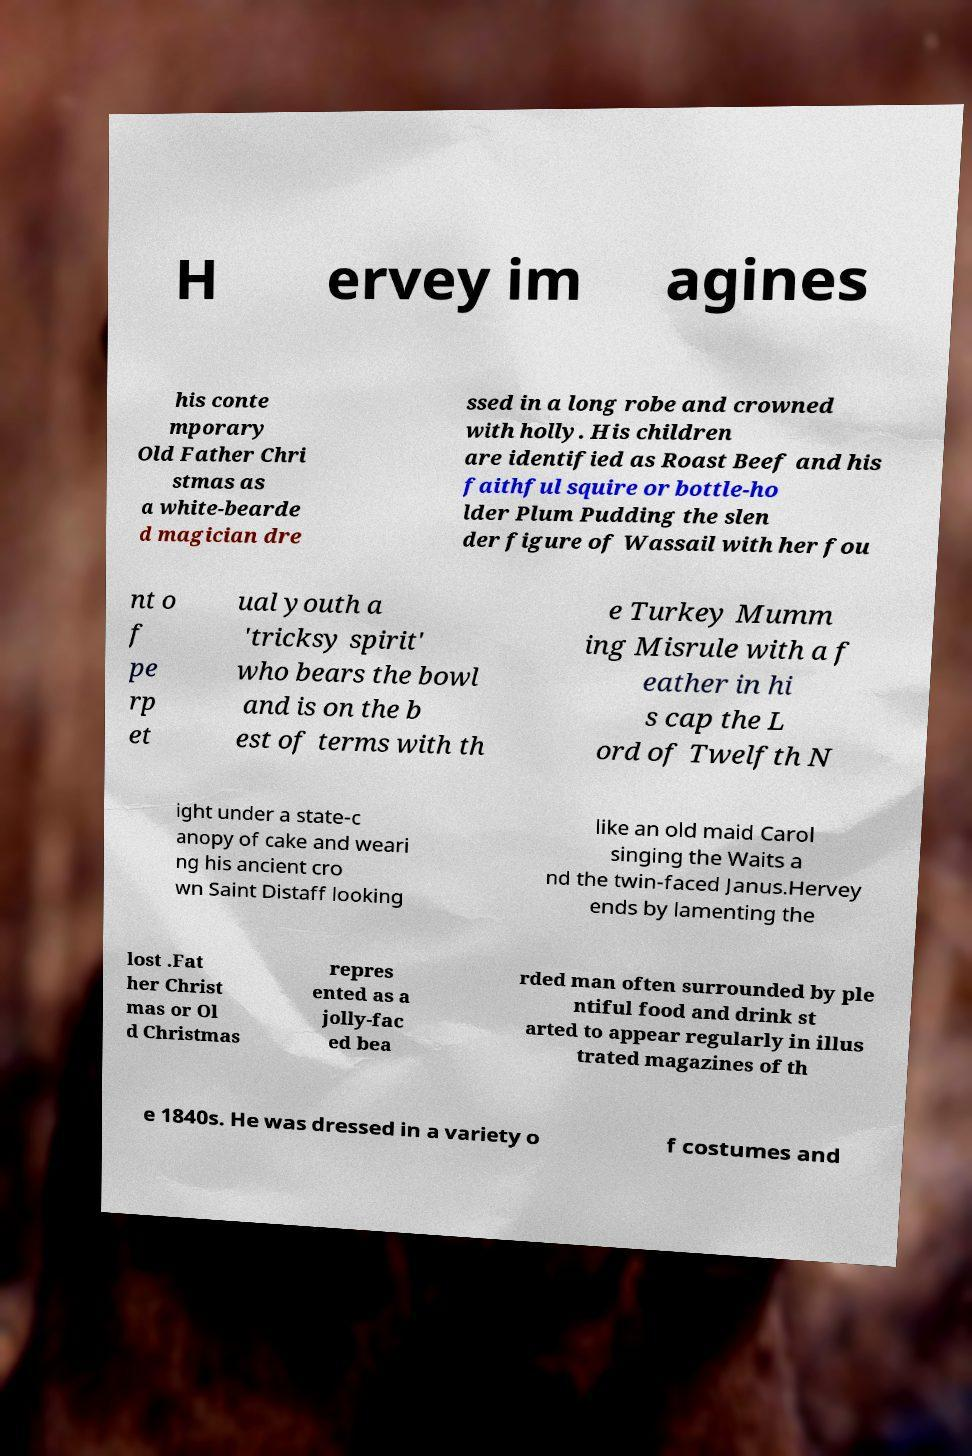Could you extract and type out the text from this image? H ervey im agines his conte mporary Old Father Chri stmas as a white-bearde d magician dre ssed in a long robe and crowned with holly. His children are identified as Roast Beef and his faithful squire or bottle-ho lder Plum Pudding the slen der figure of Wassail with her fou nt o f pe rp et ual youth a 'tricksy spirit' who bears the bowl and is on the b est of terms with th e Turkey Mumm ing Misrule with a f eather in hi s cap the L ord of Twelfth N ight under a state-c anopy of cake and weari ng his ancient cro wn Saint Distaff looking like an old maid Carol singing the Waits a nd the twin-faced Janus.Hervey ends by lamenting the lost .Fat her Christ mas or Ol d Christmas repres ented as a jolly-fac ed bea rded man often surrounded by ple ntiful food and drink st arted to appear regularly in illus trated magazines of th e 1840s. He was dressed in a variety o f costumes and 